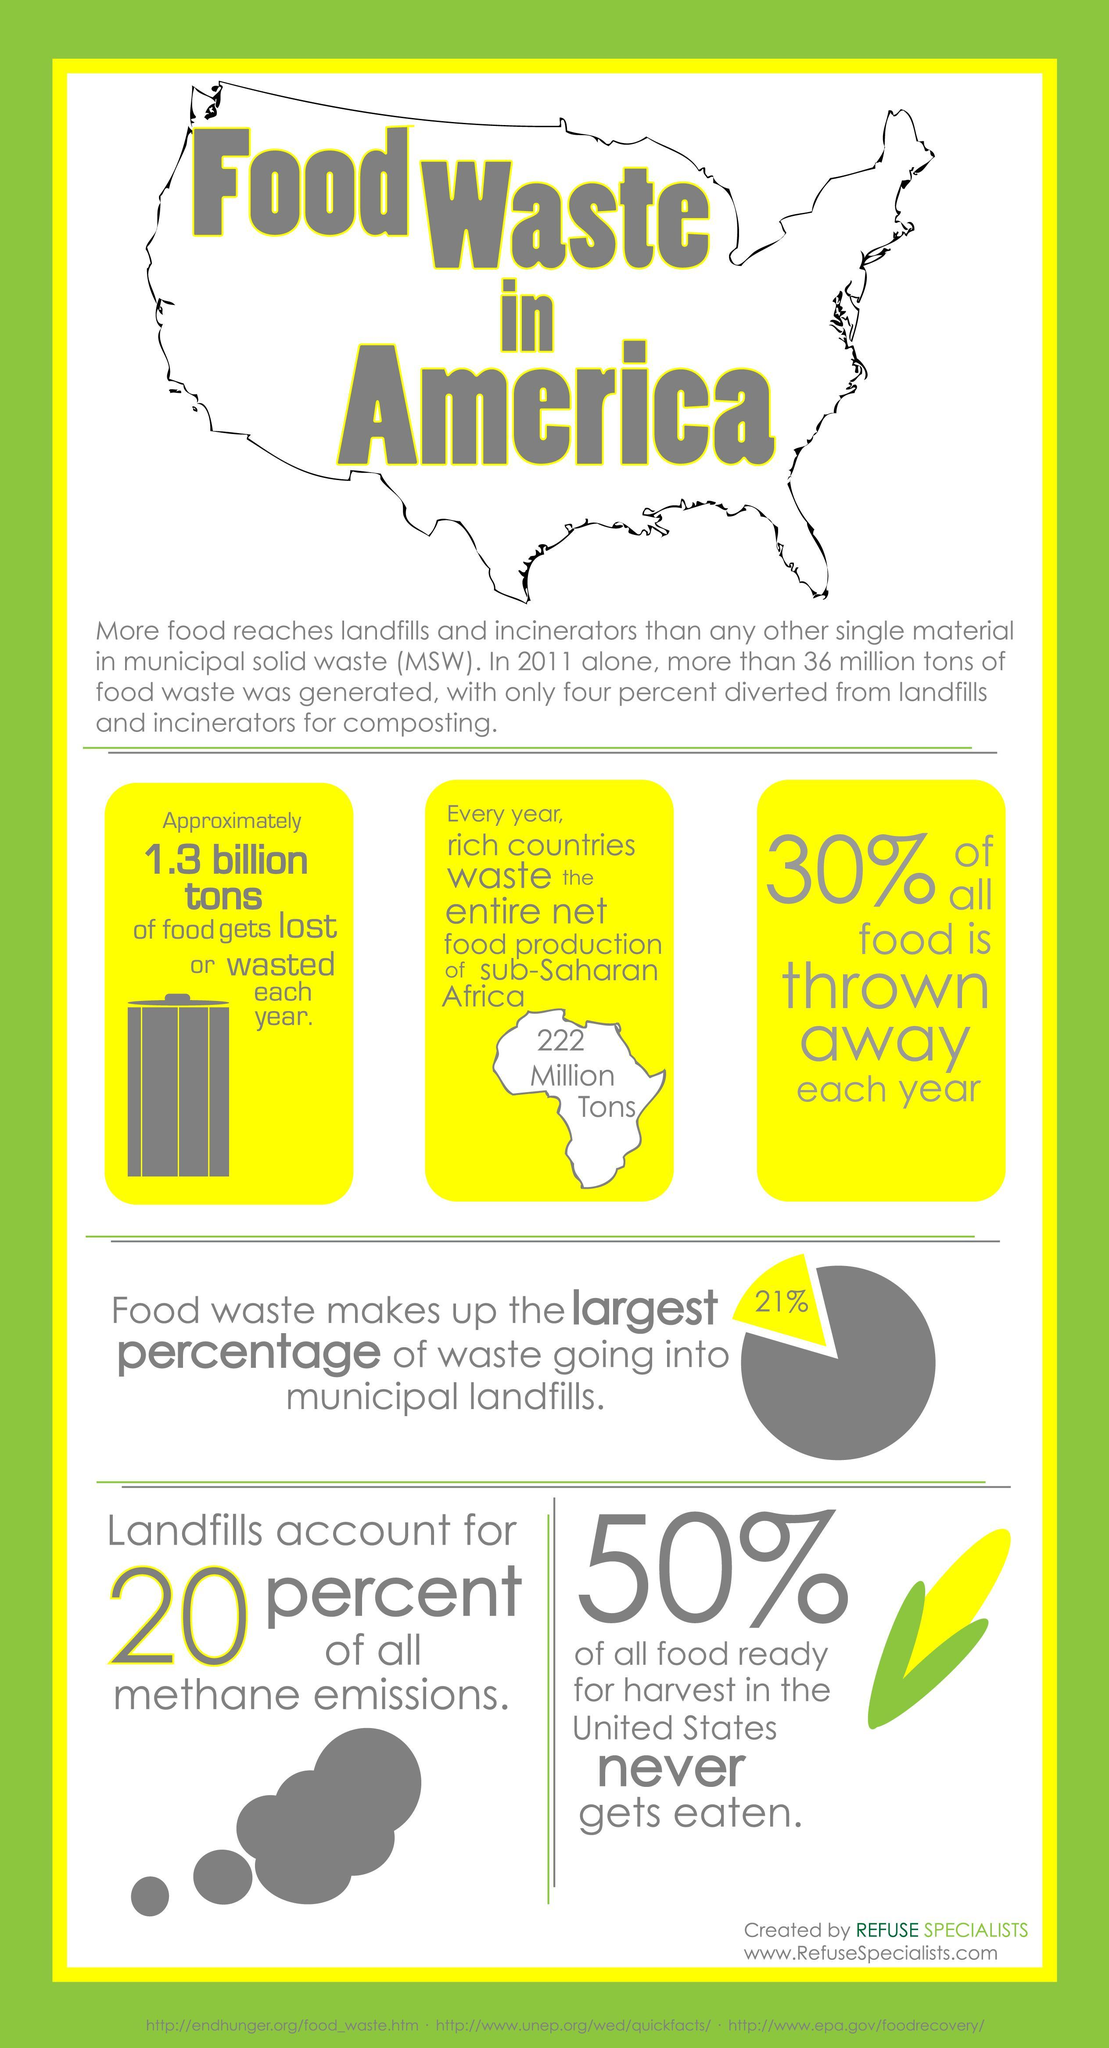What is the net food production of sub-Saharan Africa
Answer the question with a short phrase. 222 Million Tons What % of waste going to municipal landfills is from food waste 21% From where is 1/5th of the methane emissions Landfills how much food gets lost or wasted each year 1.3 billions tons What is the colour of the corn kernel, yellow or green yellow 